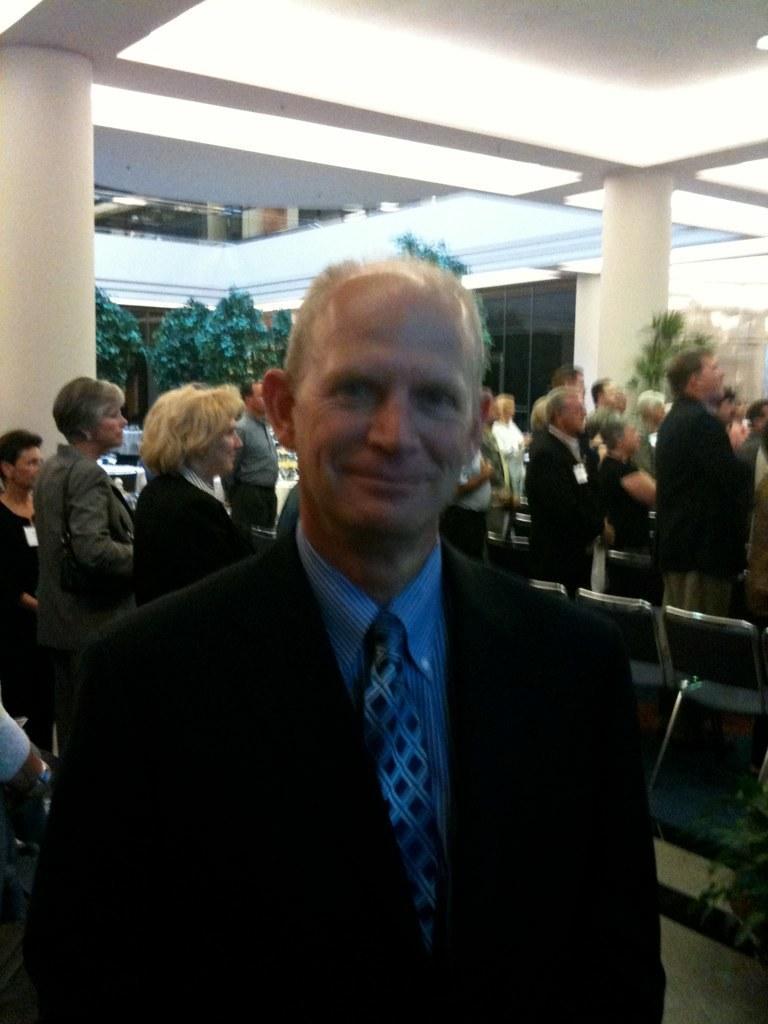Could you give a brief overview of what you see in this image? In this image I can see number of people are standing and in the background I can see few dollars and few trees. On the right side of this image I can see number of chairs and a plant. 